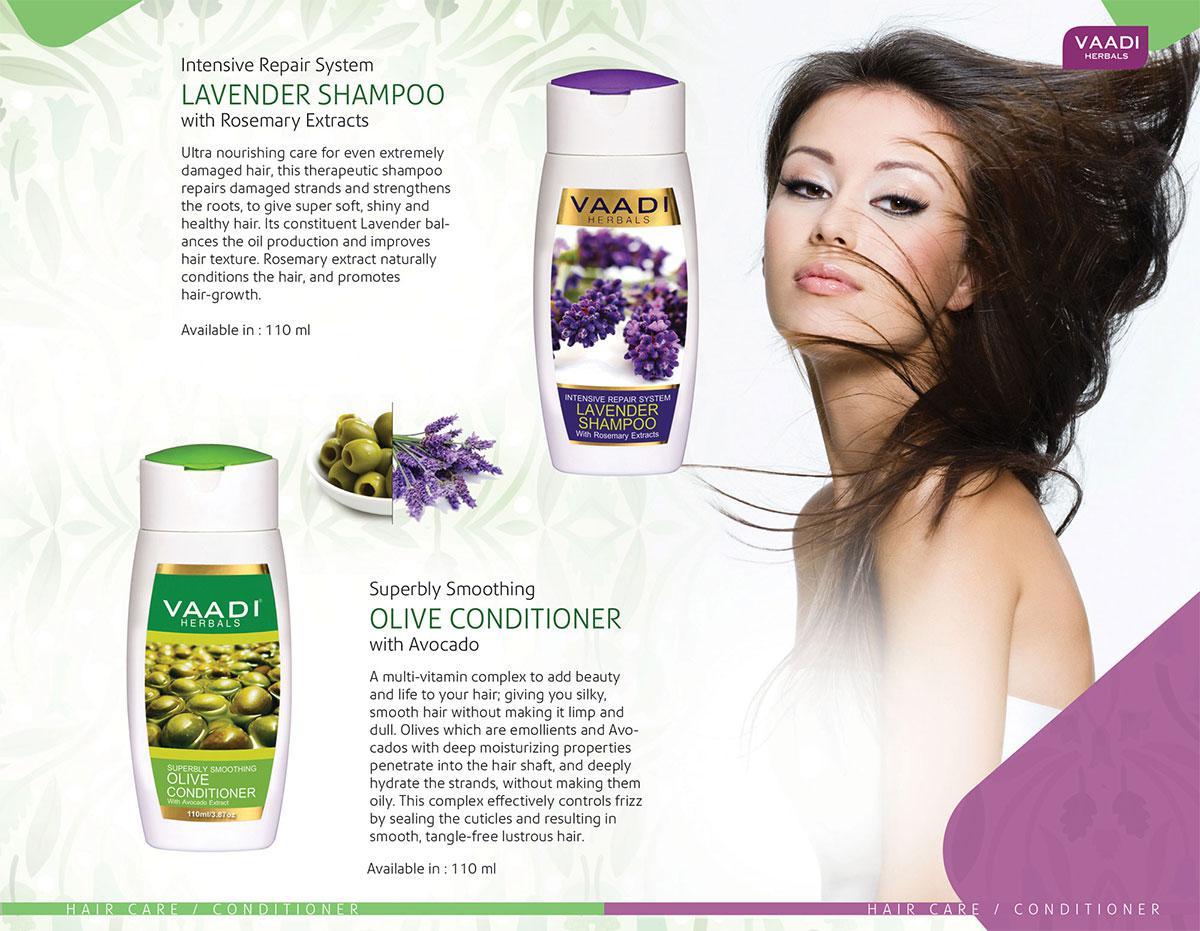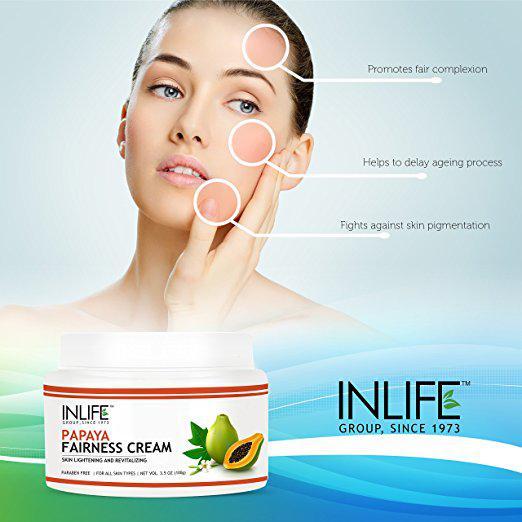The first image is the image on the left, the second image is the image on the right. Evaluate the accuracy of this statement regarding the images: "At least one woman has her hand on her face.". Is it true? Answer yes or no. Yes. The first image is the image on the left, the second image is the image on the right. Evaluate the accuracy of this statement regarding the images: "An ad image shows a model with slicked-back hair holding exactly one hand on her cheek.". Is it true? Answer yes or no. Yes. 